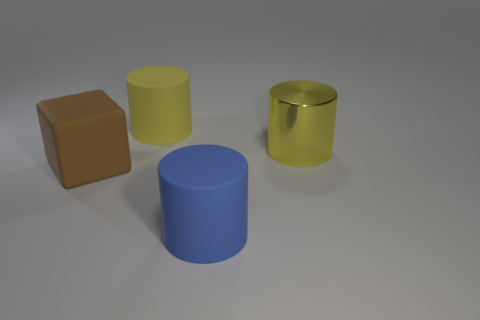Add 1 yellow cylinders. How many objects exist? 5 Subtract all cylinders. How many objects are left? 1 Add 1 large yellow rubber cylinders. How many large yellow rubber cylinders exist? 2 Subtract 0 gray blocks. How many objects are left? 4 Subtract all big matte cylinders. Subtract all large yellow cylinders. How many objects are left? 0 Add 2 metal objects. How many metal objects are left? 3 